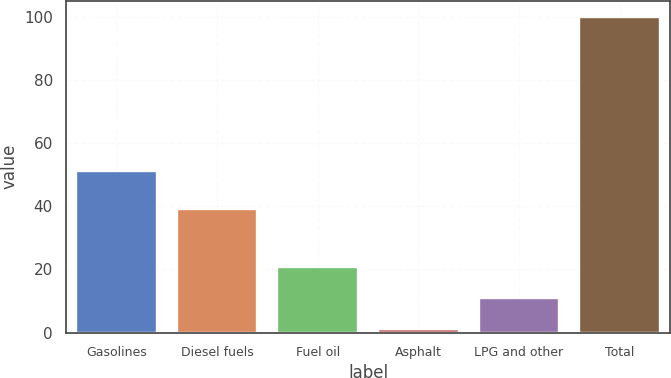Convert chart to OTSL. <chart><loc_0><loc_0><loc_500><loc_500><bar_chart><fcel>Gasolines<fcel>Diesel fuels<fcel>Fuel oil<fcel>Asphalt<fcel>LPG and other<fcel>Total<nl><fcel>51<fcel>39<fcel>20.8<fcel>1<fcel>10.9<fcel>100<nl></chart> 